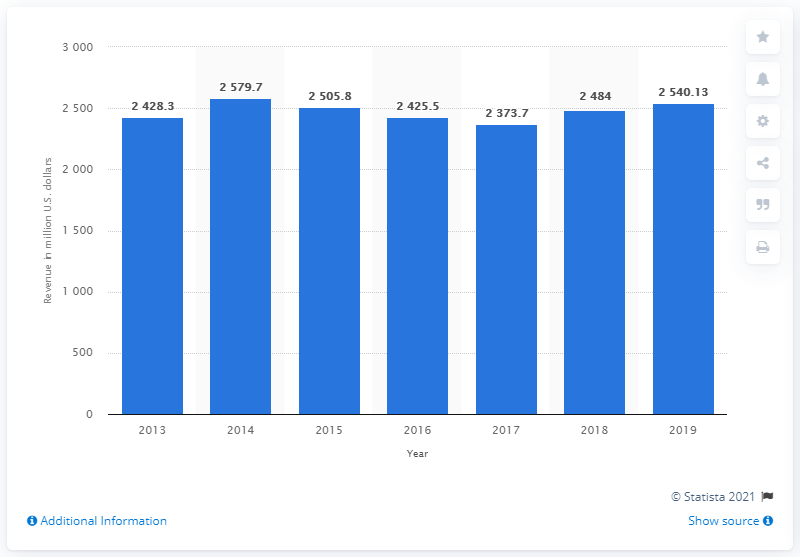Point out several critical features in this image. J. Crew's global revenue in 2019 was approximately $2540.13 million. 